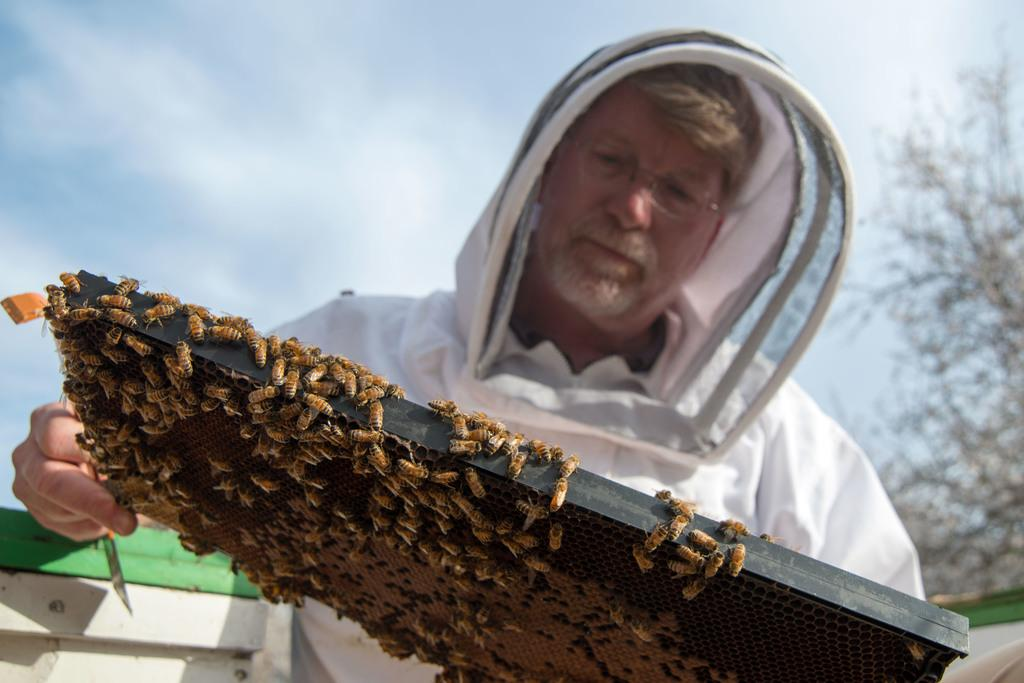Who is the main subject in the image? There is a man in the center of the image. What is the man holding in the image? The man is holding a stand. What is on the stand that the man is holding? The stand is full of honey bees. What can be seen in the background of the image? There is a tree in the background of the image. How would you describe the weather based on the image? The sky is cloudy in the image. How many pizzas are being delivered by the man in the image? There are no pizzas present in the image; the man is holding a stand full of honey bees. What trail does the man follow while holding the stand in the image? There is no trail visible in the image, and the man is stationary while holding the stand. 